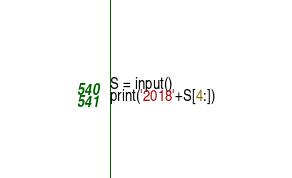Convert code to text. <code><loc_0><loc_0><loc_500><loc_500><_Python_>S = input()
print('2018'+S[4:])</code> 